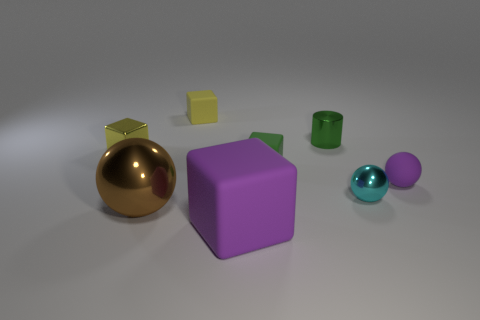Subtract 1 spheres. How many spheres are left? 2 Subtract all green cubes. How many cubes are left? 3 Subtract all gray cubes. Subtract all purple balls. How many cubes are left? 4 Add 1 balls. How many objects exist? 9 Subtract all cylinders. How many objects are left? 7 Add 1 small yellow cubes. How many small yellow cubes are left? 3 Add 5 matte objects. How many matte objects exist? 9 Subtract 0 green balls. How many objects are left? 8 Subtract all large purple matte things. Subtract all small metallic things. How many objects are left? 4 